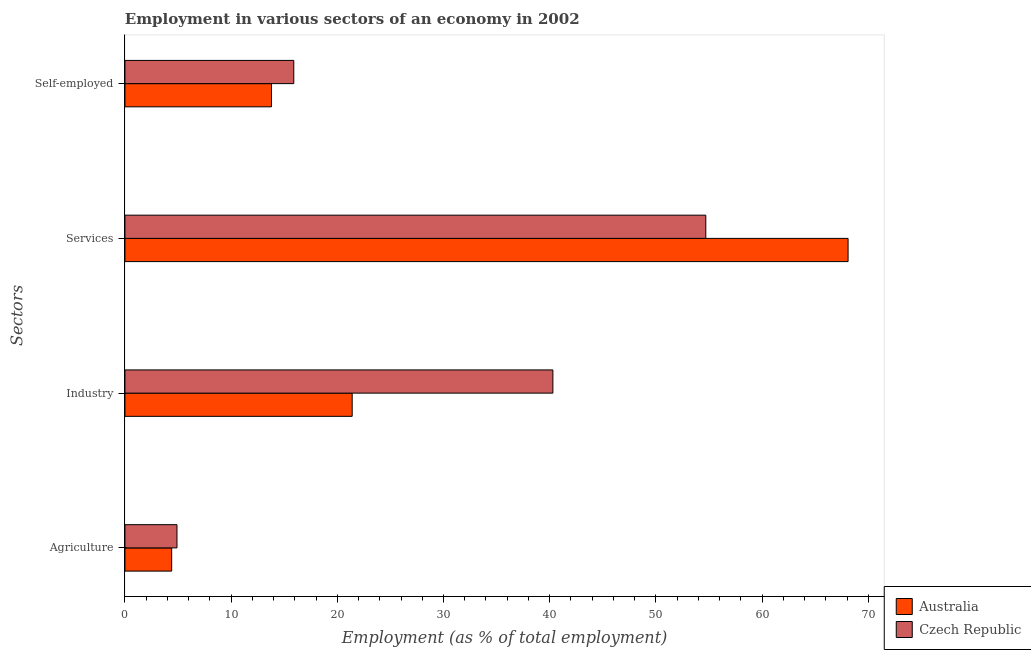How many different coloured bars are there?
Provide a succinct answer. 2. How many groups of bars are there?
Offer a terse response. 4. Are the number of bars on each tick of the Y-axis equal?
Ensure brevity in your answer.  Yes. How many bars are there on the 4th tick from the top?
Ensure brevity in your answer.  2. What is the label of the 1st group of bars from the top?
Offer a very short reply. Self-employed. What is the percentage of self employed workers in Czech Republic?
Your answer should be very brief. 15.9. Across all countries, what is the maximum percentage of self employed workers?
Your answer should be very brief. 15.9. Across all countries, what is the minimum percentage of self employed workers?
Your answer should be very brief. 13.8. In which country was the percentage of workers in industry maximum?
Your answer should be compact. Czech Republic. In which country was the percentage of workers in industry minimum?
Provide a succinct answer. Australia. What is the total percentage of workers in agriculture in the graph?
Make the answer very short. 9.3. What is the difference between the percentage of workers in agriculture in Czech Republic and that in Australia?
Make the answer very short. 0.5. What is the difference between the percentage of workers in industry in Czech Republic and the percentage of workers in agriculture in Australia?
Ensure brevity in your answer.  35.9. What is the average percentage of workers in industry per country?
Your response must be concise. 30.85. What is the difference between the percentage of self employed workers and percentage of workers in agriculture in Australia?
Provide a short and direct response. 9.4. What is the ratio of the percentage of workers in industry in Czech Republic to that in Australia?
Offer a terse response. 1.88. In how many countries, is the percentage of workers in agriculture greater than the average percentage of workers in agriculture taken over all countries?
Provide a short and direct response. 1. What does the 1st bar from the top in Agriculture represents?
Offer a very short reply. Czech Republic. What does the 2nd bar from the bottom in Self-employed represents?
Your answer should be very brief. Czech Republic. How many countries are there in the graph?
Keep it short and to the point. 2. What is the difference between two consecutive major ticks on the X-axis?
Provide a succinct answer. 10. Does the graph contain any zero values?
Provide a short and direct response. No. Where does the legend appear in the graph?
Provide a short and direct response. Bottom right. How are the legend labels stacked?
Ensure brevity in your answer.  Vertical. What is the title of the graph?
Your answer should be compact. Employment in various sectors of an economy in 2002. Does "Least developed countries" appear as one of the legend labels in the graph?
Give a very brief answer. No. What is the label or title of the X-axis?
Your answer should be compact. Employment (as % of total employment). What is the label or title of the Y-axis?
Make the answer very short. Sectors. What is the Employment (as % of total employment) of Australia in Agriculture?
Your answer should be very brief. 4.4. What is the Employment (as % of total employment) in Czech Republic in Agriculture?
Provide a succinct answer. 4.9. What is the Employment (as % of total employment) of Australia in Industry?
Provide a succinct answer. 21.4. What is the Employment (as % of total employment) of Czech Republic in Industry?
Ensure brevity in your answer.  40.3. What is the Employment (as % of total employment) of Australia in Services?
Your response must be concise. 68.1. What is the Employment (as % of total employment) of Czech Republic in Services?
Your response must be concise. 54.7. What is the Employment (as % of total employment) of Australia in Self-employed?
Offer a very short reply. 13.8. What is the Employment (as % of total employment) of Czech Republic in Self-employed?
Your answer should be compact. 15.9. Across all Sectors, what is the maximum Employment (as % of total employment) of Australia?
Your answer should be compact. 68.1. Across all Sectors, what is the maximum Employment (as % of total employment) of Czech Republic?
Your answer should be compact. 54.7. Across all Sectors, what is the minimum Employment (as % of total employment) in Australia?
Ensure brevity in your answer.  4.4. Across all Sectors, what is the minimum Employment (as % of total employment) of Czech Republic?
Offer a very short reply. 4.9. What is the total Employment (as % of total employment) of Australia in the graph?
Make the answer very short. 107.7. What is the total Employment (as % of total employment) in Czech Republic in the graph?
Provide a succinct answer. 115.8. What is the difference between the Employment (as % of total employment) in Czech Republic in Agriculture and that in Industry?
Make the answer very short. -35.4. What is the difference between the Employment (as % of total employment) in Australia in Agriculture and that in Services?
Provide a short and direct response. -63.7. What is the difference between the Employment (as % of total employment) in Czech Republic in Agriculture and that in Services?
Your answer should be compact. -49.8. What is the difference between the Employment (as % of total employment) of Australia in Agriculture and that in Self-employed?
Your response must be concise. -9.4. What is the difference between the Employment (as % of total employment) of Czech Republic in Agriculture and that in Self-employed?
Ensure brevity in your answer.  -11. What is the difference between the Employment (as % of total employment) of Australia in Industry and that in Services?
Ensure brevity in your answer.  -46.7. What is the difference between the Employment (as % of total employment) of Czech Republic in Industry and that in Services?
Your response must be concise. -14.4. What is the difference between the Employment (as % of total employment) in Czech Republic in Industry and that in Self-employed?
Keep it short and to the point. 24.4. What is the difference between the Employment (as % of total employment) of Australia in Services and that in Self-employed?
Keep it short and to the point. 54.3. What is the difference between the Employment (as % of total employment) in Czech Republic in Services and that in Self-employed?
Your answer should be compact. 38.8. What is the difference between the Employment (as % of total employment) in Australia in Agriculture and the Employment (as % of total employment) in Czech Republic in Industry?
Ensure brevity in your answer.  -35.9. What is the difference between the Employment (as % of total employment) of Australia in Agriculture and the Employment (as % of total employment) of Czech Republic in Services?
Make the answer very short. -50.3. What is the difference between the Employment (as % of total employment) in Australia in Industry and the Employment (as % of total employment) in Czech Republic in Services?
Provide a short and direct response. -33.3. What is the difference between the Employment (as % of total employment) in Australia in Industry and the Employment (as % of total employment) in Czech Republic in Self-employed?
Offer a very short reply. 5.5. What is the difference between the Employment (as % of total employment) in Australia in Services and the Employment (as % of total employment) in Czech Republic in Self-employed?
Provide a short and direct response. 52.2. What is the average Employment (as % of total employment) of Australia per Sectors?
Make the answer very short. 26.93. What is the average Employment (as % of total employment) in Czech Republic per Sectors?
Your response must be concise. 28.95. What is the difference between the Employment (as % of total employment) of Australia and Employment (as % of total employment) of Czech Republic in Agriculture?
Make the answer very short. -0.5. What is the difference between the Employment (as % of total employment) of Australia and Employment (as % of total employment) of Czech Republic in Industry?
Provide a succinct answer. -18.9. What is the ratio of the Employment (as % of total employment) of Australia in Agriculture to that in Industry?
Your response must be concise. 0.21. What is the ratio of the Employment (as % of total employment) of Czech Republic in Agriculture to that in Industry?
Ensure brevity in your answer.  0.12. What is the ratio of the Employment (as % of total employment) in Australia in Agriculture to that in Services?
Provide a short and direct response. 0.06. What is the ratio of the Employment (as % of total employment) of Czech Republic in Agriculture to that in Services?
Make the answer very short. 0.09. What is the ratio of the Employment (as % of total employment) of Australia in Agriculture to that in Self-employed?
Keep it short and to the point. 0.32. What is the ratio of the Employment (as % of total employment) in Czech Republic in Agriculture to that in Self-employed?
Your answer should be compact. 0.31. What is the ratio of the Employment (as % of total employment) in Australia in Industry to that in Services?
Keep it short and to the point. 0.31. What is the ratio of the Employment (as % of total employment) of Czech Republic in Industry to that in Services?
Give a very brief answer. 0.74. What is the ratio of the Employment (as % of total employment) of Australia in Industry to that in Self-employed?
Offer a very short reply. 1.55. What is the ratio of the Employment (as % of total employment) of Czech Republic in Industry to that in Self-employed?
Your response must be concise. 2.53. What is the ratio of the Employment (as % of total employment) of Australia in Services to that in Self-employed?
Make the answer very short. 4.93. What is the ratio of the Employment (as % of total employment) of Czech Republic in Services to that in Self-employed?
Offer a very short reply. 3.44. What is the difference between the highest and the second highest Employment (as % of total employment) in Australia?
Your answer should be very brief. 46.7. What is the difference between the highest and the second highest Employment (as % of total employment) in Czech Republic?
Keep it short and to the point. 14.4. What is the difference between the highest and the lowest Employment (as % of total employment) in Australia?
Provide a short and direct response. 63.7. What is the difference between the highest and the lowest Employment (as % of total employment) in Czech Republic?
Keep it short and to the point. 49.8. 